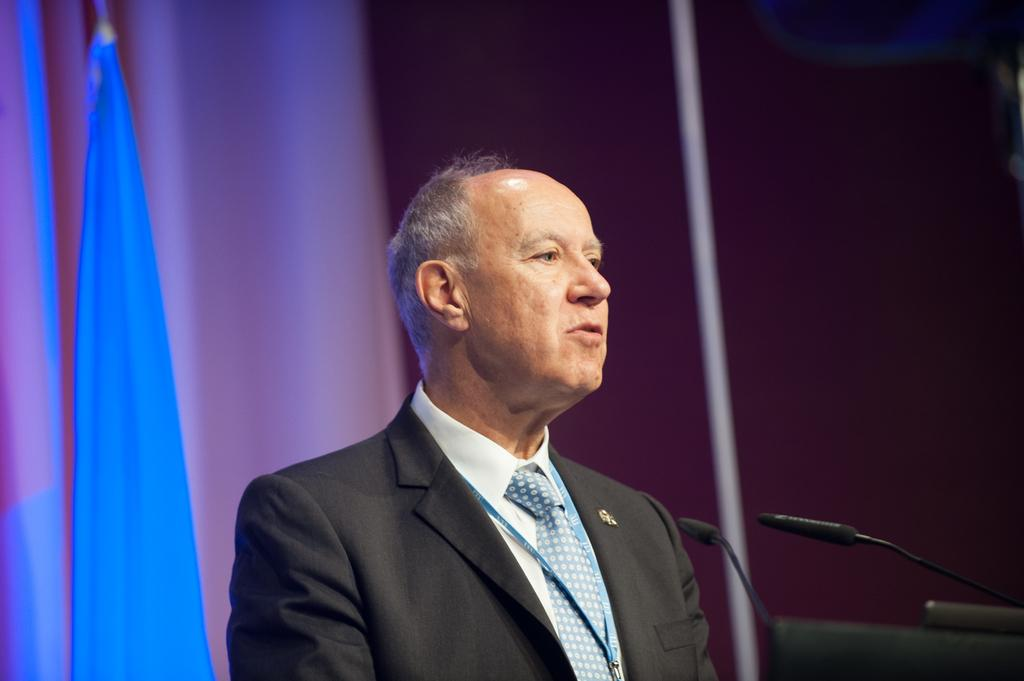Who or what is the main subject in the center of the image? There is a person in the center of the image. What objects are on the right side of the image? There are microphones on the right side of the image. What can be seen in the background of the image? There is a wall and curtains in the background of the image. Can you describe any additional details visible in the image? There is some wire visible in the image. What type of caption is written on the lake in the image? There is no lake or caption present in the image. 